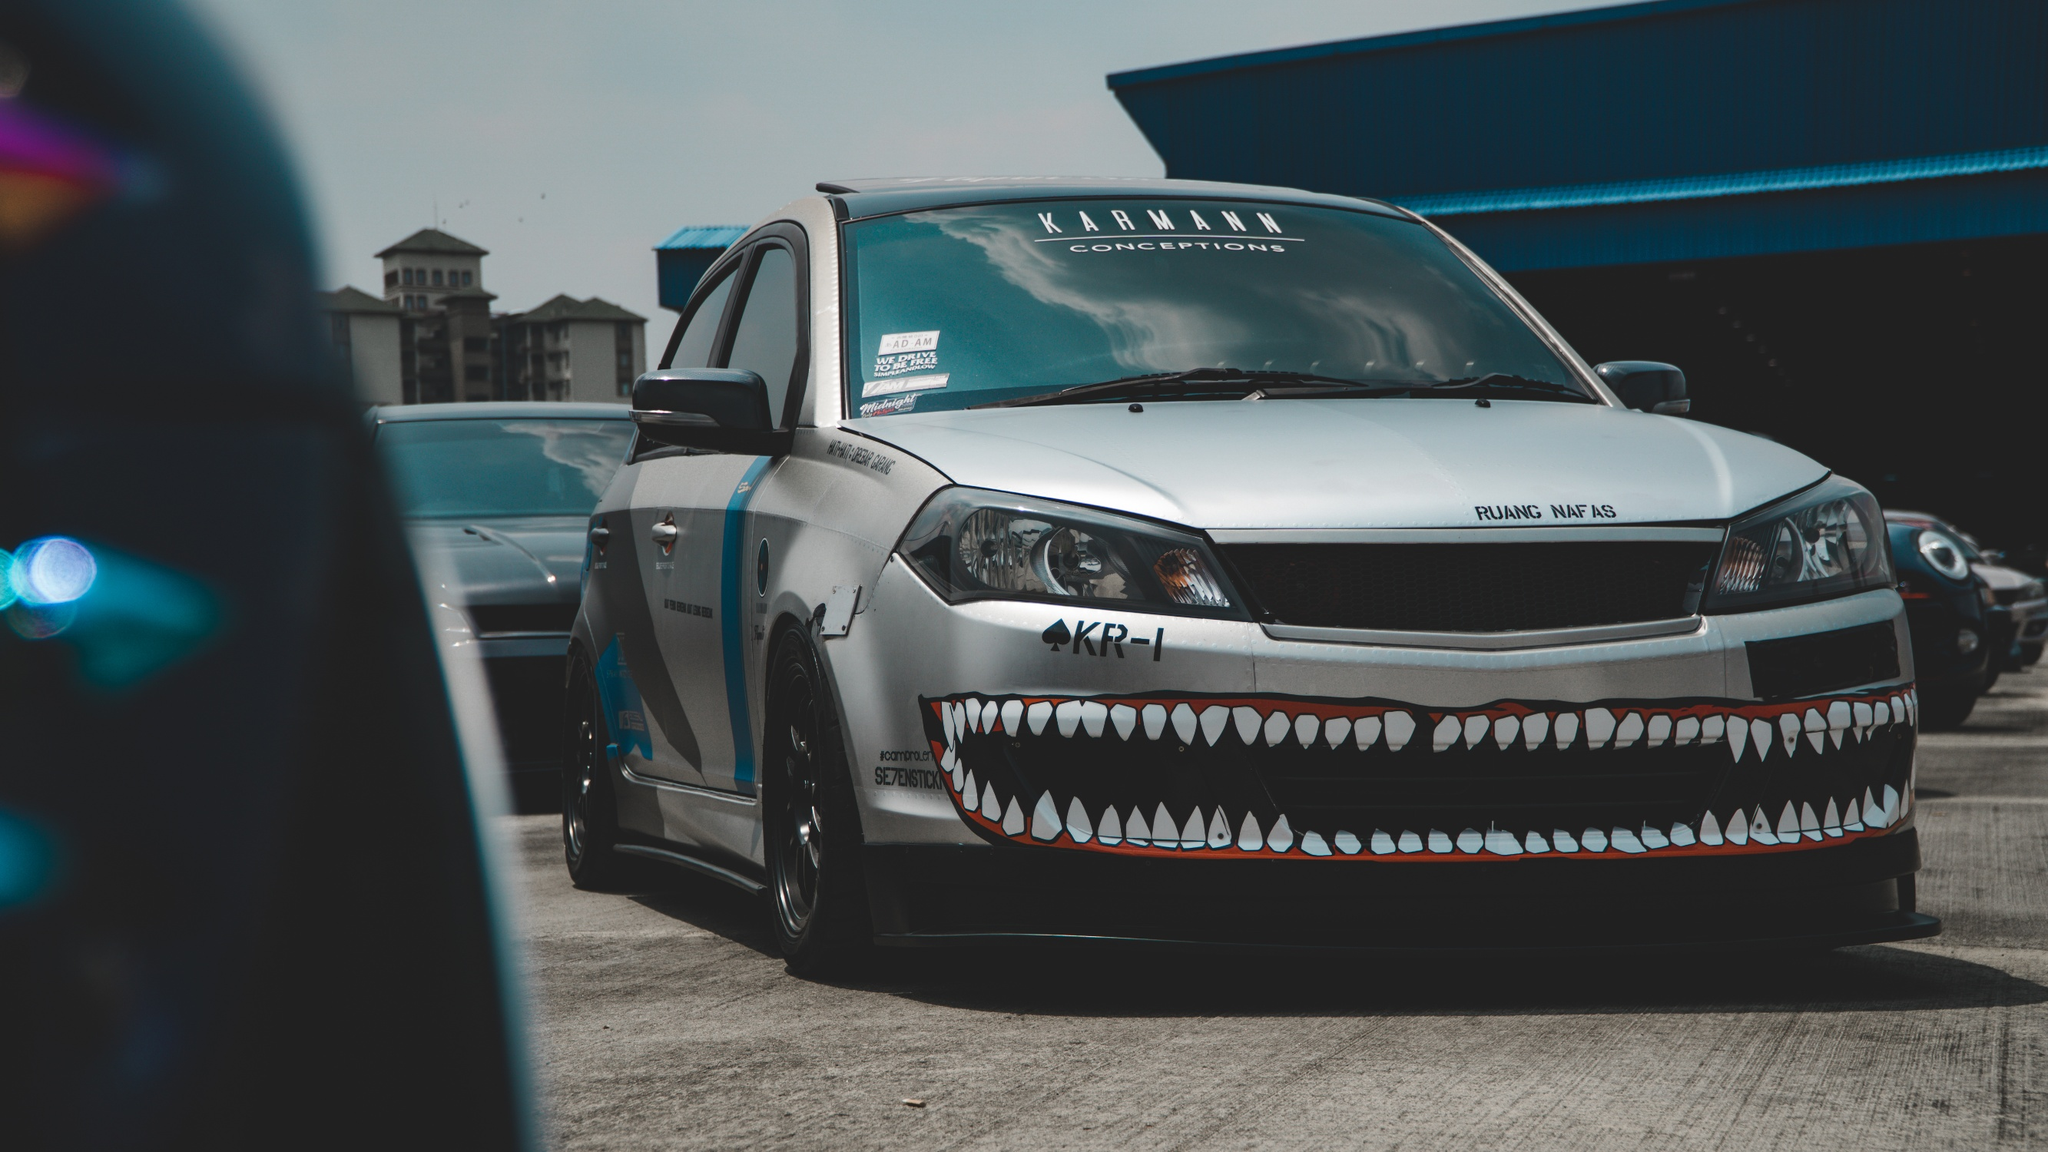What's happening in the scene? The image captures a unique and striking scene featuring a white car with a black hood, prominently parked in a lot amidst other vehicles. This car immediately draws attention due to its unconventional design, where the front bumper is artfully decorated with sharp, shark-like teeth, creating an aggressive and distinctive look. The photograph, taken from the side with a slight angle towards the front, showcases the sleek design and bold features of the car. The colors in the image are dominated by white, black, and blue tones, with the white car providing a stark contrast to its darker surroundings. In the background, a building, likely located in an urban setting, adds context to the scene. Despite the identifier "sa_14020" visible on the vehicle, no specific information about the location or any landmarks is apparent. 